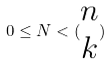Convert formula to latex. <formula><loc_0><loc_0><loc_500><loc_500>0 \leq N < ( \begin{matrix} n \\ k \end{matrix} )</formula> 